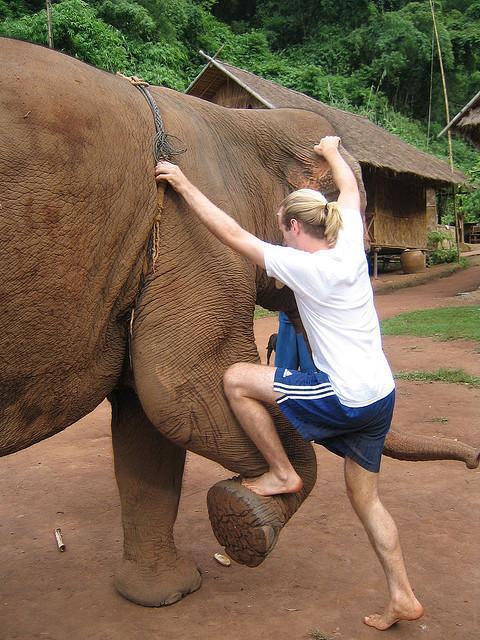Is this affirmation: "The elephant is touching the person." correct?
Answer yes or no. Yes. Is this affirmation: "The person is touching the elephant." correct?
Answer yes or no. Yes. 